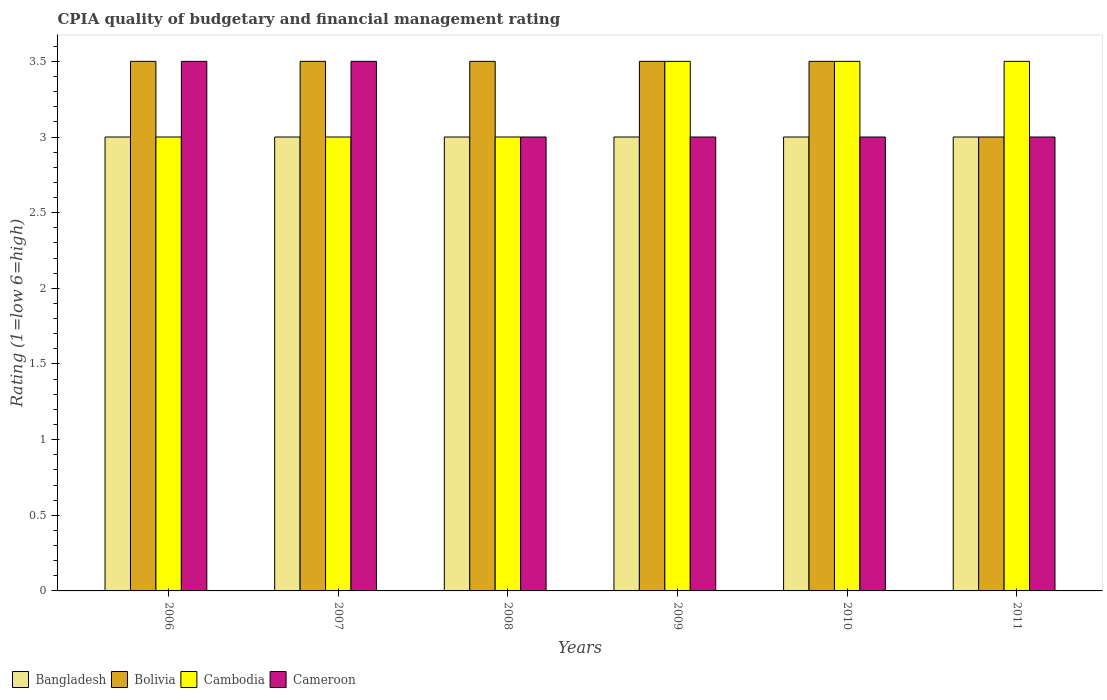How many groups of bars are there?
Your response must be concise. 6. Are the number of bars on each tick of the X-axis equal?
Provide a succinct answer. Yes. How many bars are there on the 2nd tick from the left?
Give a very brief answer. 4. What is the CPIA rating in Bangladesh in 2008?
Your answer should be compact. 3. Across all years, what is the maximum CPIA rating in Cameroon?
Your response must be concise. 3.5. Across all years, what is the minimum CPIA rating in Cameroon?
Offer a terse response. 3. In which year was the CPIA rating in Cambodia maximum?
Your answer should be very brief. 2009. In which year was the CPIA rating in Cambodia minimum?
Offer a terse response. 2006. What is the difference between the CPIA rating in Bangladesh in 2008 and the CPIA rating in Cambodia in 2009?
Your answer should be compact. -0.5. In the year 2006, what is the difference between the CPIA rating in Cambodia and CPIA rating in Bolivia?
Provide a succinct answer. -0.5. What is the ratio of the CPIA rating in Cameroon in 2006 to that in 2010?
Your response must be concise. 1.17. Is it the case that in every year, the sum of the CPIA rating in Bolivia and CPIA rating in Cameroon is greater than the sum of CPIA rating in Cambodia and CPIA rating in Bangladesh?
Your answer should be compact. No. Is it the case that in every year, the sum of the CPIA rating in Cambodia and CPIA rating in Bangladesh is greater than the CPIA rating in Bolivia?
Provide a succinct answer. Yes. How many bars are there?
Your answer should be compact. 24. What is the difference between two consecutive major ticks on the Y-axis?
Give a very brief answer. 0.5. Are the values on the major ticks of Y-axis written in scientific E-notation?
Make the answer very short. No. Does the graph contain grids?
Provide a short and direct response. No. Where does the legend appear in the graph?
Keep it short and to the point. Bottom left. What is the title of the graph?
Your answer should be very brief. CPIA quality of budgetary and financial management rating. Does "Bahamas" appear as one of the legend labels in the graph?
Your response must be concise. No. What is the label or title of the X-axis?
Ensure brevity in your answer.  Years. What is the Rating (1=low 6=high) in Cameroon in 2006?
Give a very brief answer. 3.5. What is the Rating (1=low 6=high) in Cambodia in 2007?
Offer a very short reply. 3. What is the Rating (1=low 6=high) of Bangladesh in 2008?
Keep it short and to the point. 3. What is the Rating (1=low 6=high) in Bolivia in 2008?
Keep it short and to the point. 3.5. What is the Rating (1=low 6=high) of Cambodia in 2008?
Offer a very short reply. 3. What is the Rating (1=low 6=high) in Cambodia in 2009?
Give a very brief answer. 3.5. What is the Rating (1=low 6=high) of Bolivia in 2010?
Provide a short and direct response. 3.5. What is the Rating (1=low 6=high) of Bangladesh in 2011?
Ensure brevity in your answer.  3. What is the Rating (1=low 6=high) in Bolivia in 2011?
Ensure brevity in your answer.  3. Across all years, what is the maximum Rating (1=low 6=high) of Bolivia?
Your answer should be very brief. 3.5. Across all years, what is the maximum Rating (1=low 6=high) of Cambodia?
Offer a terse response. 3.5. Across all years, what is the minimum Rating (1=low 6=high) in Bangladesh?
Make the answer very short. 3. Across all years, what is the minimum Rating (1=low 6=high) of Bolivia?
Offer a very short reply. 3. Across all years, what is the minimum Rating (1=low 6=high) of Cambodia?
Your answer should be compact. 3. What is the difference between the Rating (1=low 6=high) in Cambodia in 2006 and that in 2007?
Offer a very short reply. 0. What is the difference between the Rating (1=low 6=high) of Bangladesh in 2006 and that in 2008?
Offer a terse response. 0. What is the difference between the Rating (1=low 6=high) of Cameroon in 2006 and that in 2008?
Give a very brief answer. 0.5. What is the difference between the Rating (1=low 6=high) in Bolivia in 2006 and that in 2009?
Your response must be concise. 0. What is the difference between the Rating (1=low 6=high) of Bangladesh in 2006 and that in 2010?
Provide a succinct answer. 0. What is the difference between the Rating (1=low 6=high) of Cameroon in 2006 and that in 2011?
Provide a succinct answer. 0.5. What is the difference between the Rating (1=low 6=high) of Bangladesh in 2007 and that in 2008?
Make the answer very short. 0. What is the difference between the Rating (1=low 6=high) in Bolivia in 2007 and that in 2009?
Offer a terse response. 0. What is the difference between the Rating (1=low 6=high) of Cambodia in 2007 and that in 2009?
Keep it short and to the point. -0.5. What is the difference between the Rating (1=low 6=high) of Cameroon in 2007 and that in 2009?
Give a very brief answer. 0.5. What is the difference between the Rating (1=low 6=high) of Cambodia in 2007 and that in 2010?
Your answer should be very brief. -0.5. What is the difference between the Rating (1=low 6=high) in Cameroon in 2007 and that in 2010?
Offer a terse response. 0.5. What is the difference between the Rating (1=low 6=high) in Bolivia in 2007 and that in 2011?
Offer a terse response. 0.5. What is the difference between the Rating (1=low 6=high) of Bolivia in 2008 and that in 2009?
Offer a terse response. 0. What is the difference between the Rating (1=low 6=high) in Cambodia in 2008 and that in 2009?
Make the answer very short. -0.5. What is the difference between the Rating (1=low 6=high) of Cameroon in 2008 and that in 2009?
Ensure brevity in your answer.  0. What is the difference between the Rating (1=low 6=high) in Cameroon in 2008 and that in 2010?
Ensure brevity in your answer.  0. What is the difference between the Rating (1=low 6=high) in Bolivia in 2008 and that in 2011?
Your answer should be very brief. 0.5. What is the difference between the Rating (1=low 6=high) in Cambodia in 2008 and that in 2011?
Offer a terse response. -0.5. What is the difference between the Rating (1=low 6=high) in Cameroon in 2008 and that in 2011?
Give a very brief answer. 0. What is the difference between the Rating (1=low 6=high) of Cambodia in 2009 and that in 2010?
Give a very brief answer. 0. What is the difference between the Rating (1=low 6=high) of Bangladesh in 2009 and that in 2011?
Keep it short and to the point. 0. What is the difference between the Rating (1=low 6=high) in Bolivia in 2010 and that in 2011?
Provide a short and direct response. 0.5. What is the difference between the Rating (1=low 6=high) in Cameroon in 2010 and that in 2011?
Offer a very short reply. 0. What is the difference between the Rating (1=low 6=high) in Bangladesh in 2006 and the Rating (1=low 6=high) in Cambodia in 2007?
Your answer should be very brief. 0. What is the difference between the Rating (1=low 6=high) of Bolivia in 2006 and the Rating (1=low 6=high) of Cambodia in 2007?
Provide a succinct answer. 0.5. What is the difference between the Rating (1=low 6=high) in Bolivia in 2006 and the Rating (1=low 6=high) in Cameroon in 2007?
Keep it short and to the point. 0. What is the difference between the Rating (1=low 6=high) of Bangladesh in 2006 and the Rating (1=low 6=high) of Bolivia in 2008?
Keep it short and to the point. -0.5. What is the difference between the Rating (1=low 6=high) of Bangladesh in 2006 and the Rating (1=low 6=high) of Cambodia in 2008?
Your answer should be very brief. 0. What is the difference between the Rating (1=low 6=high) of Bangladesh in 2006 and the Rating (1=low 6=high) of Cameroon in 2008?
Provide a short and direct response. 0. What is the difference between the Rating (1=low 6=high) of Bolivia in 2006 and the Rating (1=low 6=high) of Cambodia in 2008?
Give a very brief answer. 0.5. What is the difference between the Rating (1=low 6=high) in Bolivia in 2006 and the Rating (1=low 6=high) in Cameroon in 2008?
Your response must be concise. 0.5. What is the difference between the Rating (1=low 6=high) of Bangladesh in 2006 and the Rating (1=low 6=high) of Bolivia in 2009?
Your answer should be very brief. -0.5. What is the difference between the Rating (1=low 6=high) of Bolivia in 2006 and the Rating (1=low 6=high) of Cameroon in 2009?
Offer a very short reply. 0.5. What is the difference between the Rating (1=low 6=high) of Cambodia in 2006 and the Rating (1=low 6=high) of Cameroon in 2009?
Make the answer very short. 0. What is the difference between the Rating (1=low 6=high) of Bangladesh in 2006 and the Rating (1=low 6=high) of Bolivia in 2010?
Your response must be concise. -0.5. What is the difference between the Rating (1=low 6=high) of Bangladesh in 2006 and the Rating (1=low 6=high) of Cambodia in 2010?
Offer a very short reply. -0.5. What is the difference between the Rating (1=low 6=high) of Bangladesh in 2006 and the Rating (1=low 6=high) of Cameroon in 2010?
Your response must be concise. 0. What is the difference between the Rating (1=low 6=high) in Bolivia in 2006 and the Rating (1=low 6=high) in Cambodia in 2010?
Ensure brevity in your answer.  0. What is the difference between the Rating (1=low 6=high) in Cambodia in 2006 and the Rating (1=low 6=high) in Cameroon in 2010?
Your response must be concise. 0. What is the difference between the Rating (1=low 6=high) in Bangladesh in 2006 and the Rating (1=low 6=high) in Bolivia in 2011?
Your response must be concise. 0. What is the difference between the Rating (1=low 6=high) of Bolivia in 2006 and the Rating (1=low 6=high) of Cambodia in 2011?
Give a very brief answer. 0. What is the difference between the Rating (1=low 6=high) of Bolivia in 2006 and the Rating (1=low 6=high) of Cameroon in 2011?
Your response must be concise. 0.5. What is the difference between the Rating (1=low 6=high) in Cambodia in 2006 and the Rating (1=low 6=high) in Cameroon in 2011?
Your response must be concise. 0. What is the difference between the Rating (1=low 6=high) in Bangladesh in 2007 and the Rating (1=low 6=high) in Bolivia in 2008?
Your answer should be very brief. -0.5. What is the difference between the Rating (1=low 6=high) in Bangladesh in 2007 and the Rating (1=low 6=high) in Cambodia in 2008?
Make the answer very short. 0. What is the difference between the Rating (1=low 6=high) of Bangladesh in 2007 and the Rating (1=low 6=high) of Cameroon in 2008?
Give a very brief answer. 0. What is the difference between the Rating (1=low 6=high) in Bolivia in 2007 and the Rating (1=low 6=high) in Cambodia in 2008?
Offer a terse response. 0.5. What is the difference between the Rating (1=low 6=high) of Bangladesh in 2007 and the Rating (1=low 6=high) of Cameroon in 2009?
Your response must be concise. 0. What is the difference between the Rating (1=low 6=high) in Bolivia in 2007 and the Rating (1=low 6=high) in Cambodia in 2009?
Offer a terse response. 0. What is the difference between the Rating (1=low 6=high) of Cambodia in 2007 and the Rating (1=low 6=high) of Cameroon in 2009?
Your answer should be very brief. 0. What is the difference between the Rating (1=low 6=high) in Bangladesh in 2007 and the Rating (1=low 6=high) in Bolivia in 2010?
Ensure brevity in your answer.  -0.5. What is the difference between the Rating (1=low 6=high) in Bangladesh in 2007 and the Rating (1=low 6=high) in Cambodia in 2010?
Provide a short and direct response. -0.5. What is the difference between the Rating (1=low 6=high) of Bolivia in 2007 and the Rating (1=low 6=high) of Cameroon in 2010?
Provide a short and direct response. 0.5. What is the difference between the Rating (1=low 6=high) in Bangladesh in 2007 and the Rating (1=low 6=high) in Bolivia in 2011?
Keep it short and to the point. 0. What is the difference between the Rating (1=low 6=high) of Bangladesh in 2007 and the Rating (1=low 6=high) of Cameroon in 2011?
Make the answer very short. 0. What is the difference between the Rating (1=low 6=high) in Bolivia in 2007 and the Rating (1=low 6=high) in Cambodia in 2011?
Your response must be concise. 0. What is the difference between the Rating (1=low 6=high) of Bangladesh in 2008 and the Rating (1=low 6=high) of Bolivia in 2009?
Provide a succinct answer. -0.5. What is the difference between the Rating (1=low 6=high) of Bangladesh in 2008 and the Rating (1=low 6=high) of Cameroon in 2009?
Provide a succinct answer. 0. What is the difference between the Rating (1=low 6=high) of Bolivia in 2008 and the Rating (1=low 6=high) of Cambodia in 2009?
Ensure brevity in your answer.  0. What is the difference between the Rating (1=low 6=high) in Bolivia in 2008 and the Rating (1=low 6=high) in Cameroon in 2009?
Provide a short and direct response. 0.5. What is the difference between the Rating (1=low 6=high) of Cambodia in 2008 and the Rating (1=low 6=high) of Cameroon in 2009?
Your answer should be very brief. 0. What is the difference between the Rating (1=low 6=high) of Bangladesh in 2008 and the Rating (1=low 6=high) of Cambodia in 2010?
Provide a succinct answer. -0.5. What is the difference between the Rating (1=low 6=high) of Bolivia in 2008 and the Rating (1=low 6=high) of Cameroon in 2010?
Your response must be concise. 0.5. What is the difference between the Rating (1=low 6=high) of Bangladesh in 2008 and the Rating (1=low 6=high) of Bolivia in 2011?
Offer a terse response. 0. What is the difference between the Rating (1=low 6=high) in Bangladesh in 2008 and the Rating (1=low 6=high) in Cambodia in 2011?
Your answer should be compact. -0.5. What is the difference between the Rating (1=low 6=high) in Bangladesh in 2008 and the Rating (1=low 6=high) in Cameroon in 2011?
Provide a short and direct response. 0. What is the difference between the Rating (1=low 6=high) of Bolivia in 2008 and the Rating (1=low 6=high) of Cambodia in 2011?
Give a very brief answer. 0. What is the difference between the Rating (1=low 6=high) of Bolivia in 2008 and the Rating (1=low 6=high) of Cameroon in 2011?
Offer a terse response. 0.5. What is the difference between the Rating (1=low 6=high) in Cambodia in 2008 and the Rating (1=low 6=high) in Cameroon in 2011?
Your answer should be very brief. 0. What is the difference between the Rating (1=low 6=high) in Bangladesh in 2009 and the Rating (1=low 6=high) in Bolivia in 2010?
Ensure brevity in your answer.  -0.5. What is the difference between the Rating (1=low 6=high) of Bangladesh in 2009 and the Rating (1=low 6=high) of Cameroon in 2010?
Make the answer very short. 0. What is the difference between the Rating (1=low 6=high) of Bolivia in 2009 and the Rating (1=low 6=high) of Cambodia in 2010?
Offer a very short reply. 0. What is the difference between the Rating (1=low 6=high) in Bolivia in 2009 and the Rating (1=low 6=high) in Cameroon in 2010?
Offer a terse response. 0.5. What is the difference between the Rating (1=low 6=high) in Bangladesh in 2009 and the Rating (1=low 6=high) in Bolivia in 2011?
Provide a short and direct response. 0. What is the difference between the Rating (1=low 6=high) in Bolivia in 2009 and the Rating (1=low 6=high) in Cameroon in 2011?
Provide a succinct answer. 0.5. What is the difference between the Rating (1=low 6=high) of Bangladesh in 2010 and the Rating (1=low 6=high) of Bolivia in 2011?
Provide a succinct answer. 0. What is the difference between the Rating (1=low 6=high) of Bangladesh in 2010 and the Rating (1=low 6=high) of Cameroon in 2011?
Your answer should be very brief. 0. What is the difference between the Rating (1=low 6=high) in Cambodia in 2010 and the Rating (1=low 6=high) in Cameroon in 2011?
Ensure brevity in your answer.  0.5. What is the average Rating (1=low 6=high) of Bolivia per year?
Provide a succinct answer. 3.42. What is the average Rating (1=low 6=high) of Cambodia per year?
Provide a succinct answer. 3.25. What is the average Rating (1=low 6=high) of Cameroon per year?
Ensure brevity in your answer.  3.17. In the year 2006, what is the difference between the Rating (1=low 6=high) in Bangladesh and Rating (1=low 6=high) in Bolivia?
Make the answer very short. -0.5. In the year 2006, what is the difference between the Rating (1=low 6=high) of Bangladesh and Rating (1=low 6=high) of Cambodia?
Make the answer very short. 0. In the year 2006, what is the difference between the Rating (1=low 6=high) in Bangladesh and Rating (1=low 6=high) in Cameroon?
Make the answer very short. -0.5. In the year 2006, what is the difference between the Rating (1=low 6=high) of Bolivia and Rating (1=low 6=high) of Cameroon?
Offer a very short reply. 0. In the year 2007, what is the difference between the Rating (1=low 6=high) of Bangladesh and Rating (1=low 6=high) of Cambodia?
Ensure brevity in your answer.  0. In the year 2008, what is the difference between the Rating (1=low 6=high) in Bangladesh and Rating (1=low 6=high) in Cameroon?
Offer a terse response. 0. In the year 2009, what is the difference between the Rating (1=low 6=high) in Bangladesh and Rating (1=low 6=high) in Bolivia?
Your answer should be very brief. -0.5. In the year 2009, what is the difference between the Rating (1=low 6=high) of Bangladesh and Rating (1=low 6=high) of Cambodia?
Ensure brevity in your answer.  -0.5. In the year 2009, what is the difference between the Rating (1=low 6=high) in Bangladesh and Rating (1=low 6=high) in Cameroon?
Make the answer very short. 0. In the year 2009, what is the difference between the Rating (1=low 6=high) in Bolivia and Rating (1=low 6=high) in Cameroon?
Provide a short and direct response. 0.5. In the year 2010, what is the difference between the Rating (1=low 6=high) in Bangladesh and Rating (1=low 6=high) in Bolivia?
Your answer should be compact. -0.5. In the year 2010, what is the difference between the Rating (1=low 6=high) in Bangladesh and Rating (1=low 6=high) in Cambodia?
Your answer should be very brief. -0.5. In the year 2010, what is the difference between the Rating (1=low 6=high) in Bangladesh and Rating (1=low 6=high) in Cameroon?
Keep it short and to the point. 0. In the year 2011, what is the difference between the Rating (1=low 6=high) of Bangladesh and Rating (1=low 6=high) of Bolivia?
Offer a terse response. 0. In the year 2011, what is the difference between the Rating (1=low 6=high) of Bolivia and Rating (1=low 6=high) of Cambodia?
Provide a short and direct response. -0.5. In the year 2011, what is the difference between the Rating (1=low 6=high) of Bolivia and Rating (1=low 6=high) of Cameroon?
Offer a terse response. 0. What is the ratio of the Rating (1=low 6=high) in Bolivia in 2006 to that in 2007?
Provide a succinct answer. 1. What is the ratio of the Rating (1=low 6=high) in Cambodia in 2006 to that in 2007?
Ensure brevity in your answer.  1. What is the ratio of the Rating (1=low 6=high) in Bangladesh in 2006 to that in 2008?
Make the answer very short. 1. What is the ratio of the Rating (1=low 6=high) of Bolivia in 2006 to that in 2008?
Your response must be concise. 1. What is the ratio of the Rating (1=low 6=high) in Cambodia in 2006 to that in 2008?
Your response must be concise. 1. What is the ratio of the Rating (1=low 6=high) of Bangladesh in 2006 to that in 2009?
Offer a terse response. 1. What is the ratio of the Rating (1=low 6=high) of Bolivia in 2006 to that in 2009?
Ensure brevity in your answer.  1. What is the ratio of the Rating (1=low 6=high) of Cameroon in 2006 to that in 2009?
Your response must be concise. 1.17. What is the ratio of the Rating (1=low 6=high) in Bangladesh in 2006 to that in 2010?
Your answer should be compact. 1. What is the ratio of the Rating (1=low 6=high) of Bolivia in 2006 to that in 2010?
Ensure brevity in your answer.  1. What is the ratio of the Rating (1=low 6=high) of Cambodia in 2006 to that in 2010?
Your answer should be compact. 0.86. What is the ratio of the Rating (1=low 6=high) in Bolivia in 2006 to that in 2011?
Give a very brief answer. 1.17. What is the ratio of the Rating (1=low 6=high) of Cambodia in 2006 to that in 2011?
Provide a short and direct response. 0.86. What is the ratio of the Rating (1=low 6=high) of Bangladesh in 2007 to that in 2008?
Offer a very short reply. 1. What is the ratio of the Rating (1=low 6=high) of Bolivia in 2007 to that in 2008?
Your response must be concise. 1. What is the ratio of the Rating (1=low 6=high) in Bangladesh in 2007 to that in 2009?
Ensure brevity in your answer.  1. What is the ratio of the Rating (1=low 6=high) of Bolivia in 2007 to that in 2010?
Your response must be concise. 1. What is the ratio of the Rating (1=low 6=high) of Cambodia in 2007 to that in 2010?
Your answer should be very brief. 0.86. What is the ratio of the Rating (1=low 6=high) of Cameroon in 2007 to that in 2010?
Make the answer very short. 1.17. What is the ratio of the Rating (1=low 6=high) in Bangladesh in 2007 to that in 2011?
Provide a succinct answer. 1. What is the ratio of the Rating (1=low 6=high) in Bolivia in 2007 to that in 2011?
Your answer should be very brief. 1.17. What is the ratio of the Rating (1=low 6=high) in Cambodia in 2007 to that in 2011?
Offer a very short reply. 0.86. What is the ratio of the Rating (1=low 6=high) in Bangladesh in 2008 to that in 2009?
Your response must be concise. 1. What is the ratio of the Rating (1=low 6=high) of Bolivia in 2008 to that in 2009?
Make the answer very short. 1. What is the ratio of the Rating (1=low 6=high) of Cambodia in 2008 to that in 2009?
Ensure brevity in your answer.  0.86. What is the ratio of the Rating (1=low 6=high) in Bangladesh in 2008 to that in 2010?
Provide a succinct answer. 1. What is the ratio of the Rating (1=low 6=high) in Cameroon in 2008 to that in 2010?
Make the answer very short. 1. What is the ratio of the Rating (1=low 6=high) of Bangladesh in 2008 to that in 2011?
Your answer should be very brief. 1. What is the ratio of the Rating (1=low 6=high) of Cameroon in 2008 to that in 2011?
Offer a very short reply. 1. What is the ratio of the Rating (1=low 6=high) of Bolivia in 2009 to that in 2010?
Your response must be concise. 1. What is the ratio of the Rating (1=low 6=high) in Cambodia in 2009 to that in 2010?
Provide a succinct answer. 1. What is the ratio of the Rating (1=low 6=high) in Cameroon in 2009 to that in 2010?
Your response must be concise. 1. What is the ratio of the Rating (1=low 6=high) of Bangladesh in 2009 to that in 2011?
Your answer should be compact. 1. What is the ratio of the Rating (1=low 6=high) of Cambodia in 2009 to that in 2011?
Give a very brief answer. 1. What is the ratio of the Rating (1=low 6=high) in Bolivia in 2010 to that in 2011?
Offer a terse response. 1.17. What is the ratio of the Rating (1=low 6=high) of Cambodia in 2010 to that in 2011?
Offer a terse response. 1. What is the ratio of the Rating (1=low 6=high) in Cameroon in 2010 to that in 2011?
Your answer should be compact. 1. What is the difference between the highest and the second highest Rating (1=low 6=high) of Bangladesh?
Offer a very short reply. 0. What is the difference between the highest and the second highest Rating (1=low 6=high) in Cambodia?
Provide a short and direct response. 0. What is the difference between the highest and the lowest Rating (1=low 6=high) in Bangladesh?
Your answer should be compact. 0. What is the difference between the highest and the lowest Rating (1=low 6=high) in Cambodia?
Keep it short and to the point. 0.5. What is the difference between the highest and the lowest Rating (1=low 6=high) of Cameroon?
Keep it short and to the point. 0.5. 